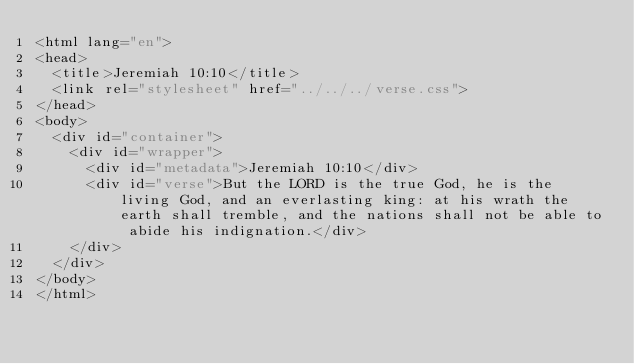<code> <loc_0><loc_0><loc_500><loc_500><_HTML_><html lang="en">
<head>
  <title>Jeremiah 10:10</title>
  <link rel="stylesheet" href="../../../verse.css">
</head>
<body>
  <div id="container">
    <div id="wrapper">
      <div id="metadata">Jeremiah 10:10</div>
      <div id="verse">But the LORD is the true God, he is the living God, and an everlasting king: at his wrath the earth shall tremble, and the nations shall not be able to abide his indignation.</div>
    </div>
  </div>
</body>
</html></code> 